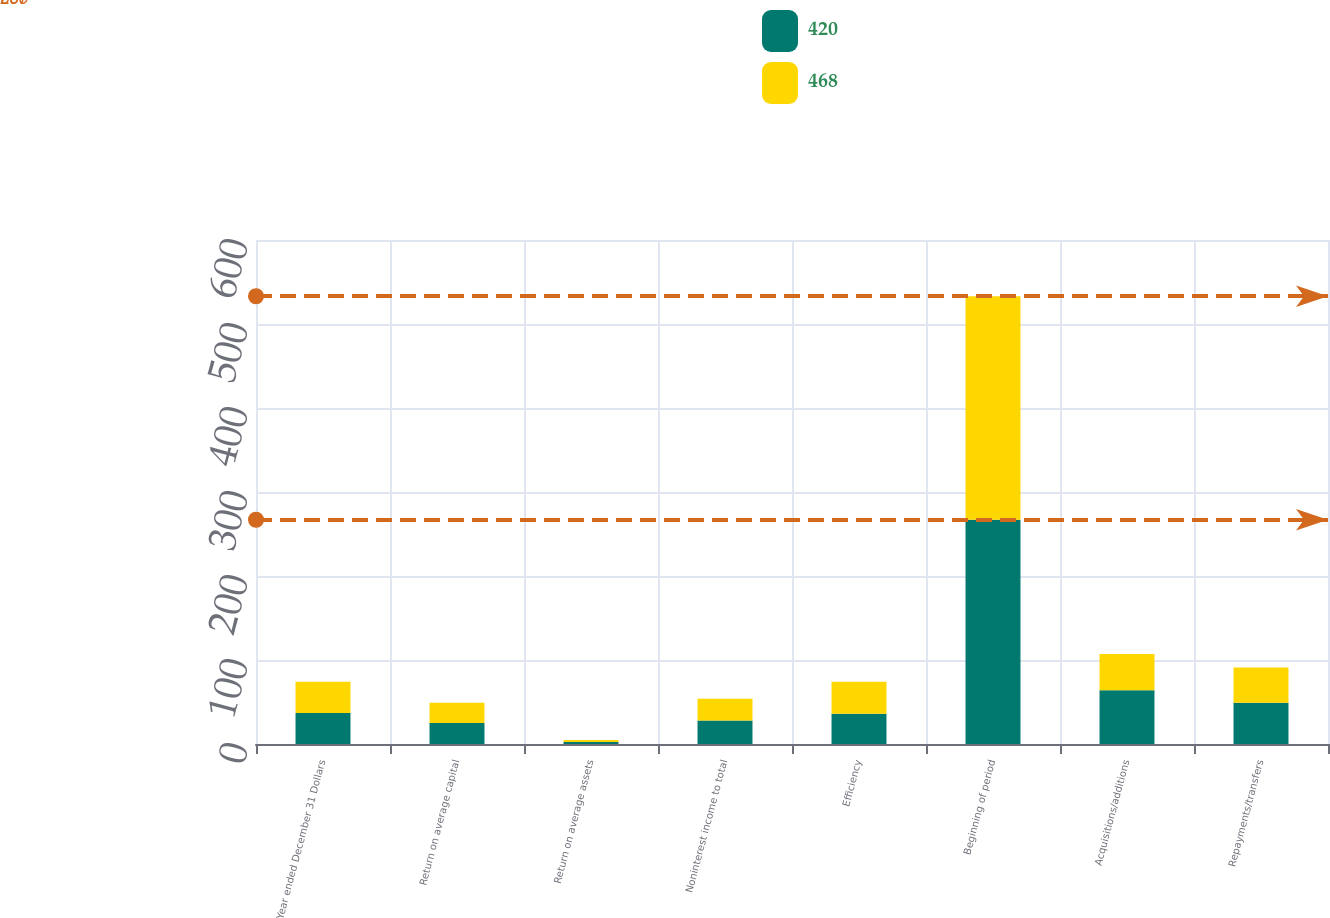Convert chart. <chart><loc_0><loc_0><loc_500><loc_500><stacked_bar_chart><ecel><fcel>Year ended December 31 Dollars<fcel>Return on average capital<fcel>Return on average assets<fcel>Noninterest income to total<fcel>Efficiency<fcel>Beginning of period<fcel>Acquisitions/additions<fcel>Repayments/transfers<nl><fcel>420<fcel>37<fcel>25<fcel>2.26<fcel>28<fcel>36<fcel>267<fcel>64<fcel>49<nl><fcel>468<fcel>37<fcel>24<fcel>2.39<fcel>26<fcel>38<fcel>266<fcel>43<fcel>42<nl></chart> 